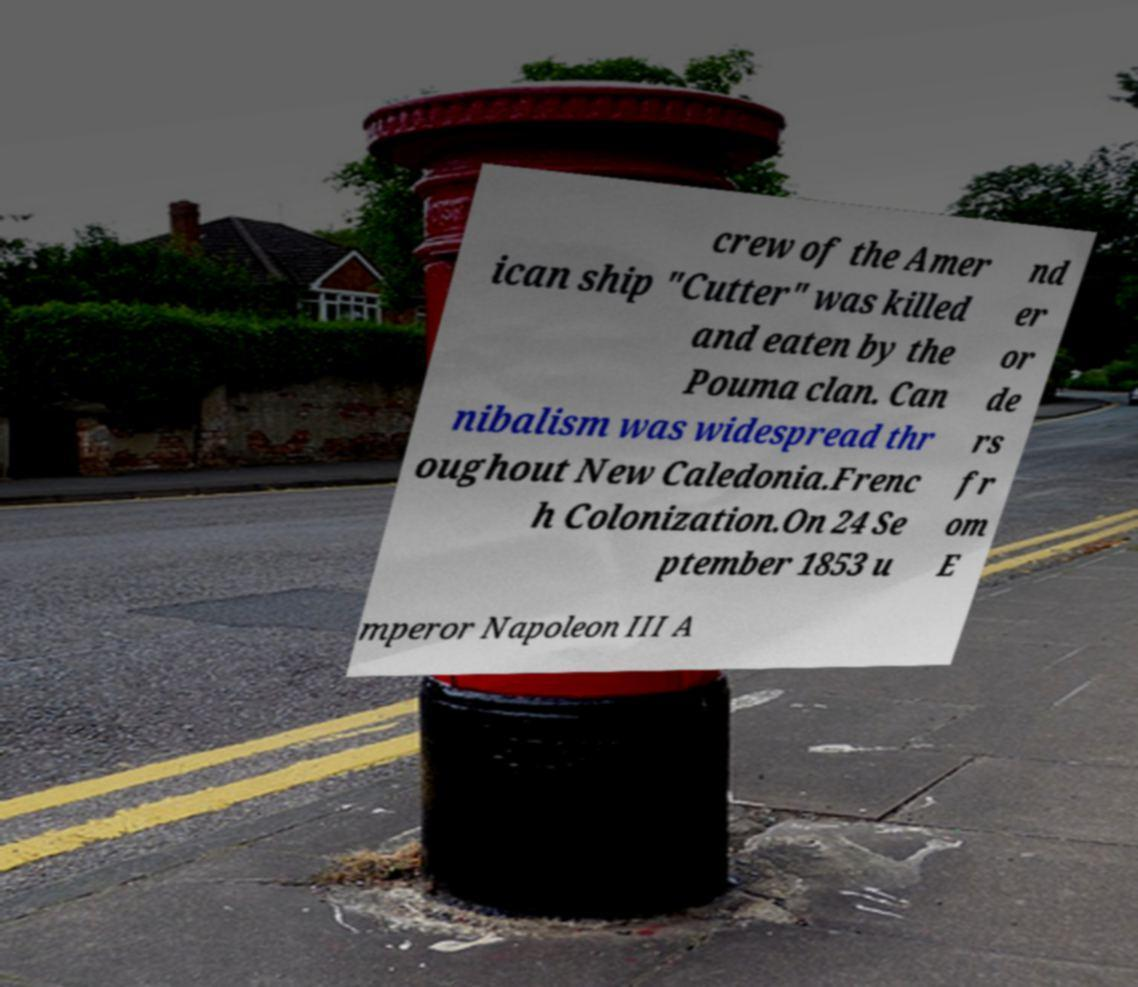Could you assist in decoding the text presented in this image and type it out clearly? crew of the Amer ican ship "Cutter" was killed and eaten by the Pouma clan. Can nibalism was widespread thr oughout New Caledonia.Frenc h Colonization.On 24 Se ptember 1853 u nd er or de rs fr om E mperor Napoleon III A 